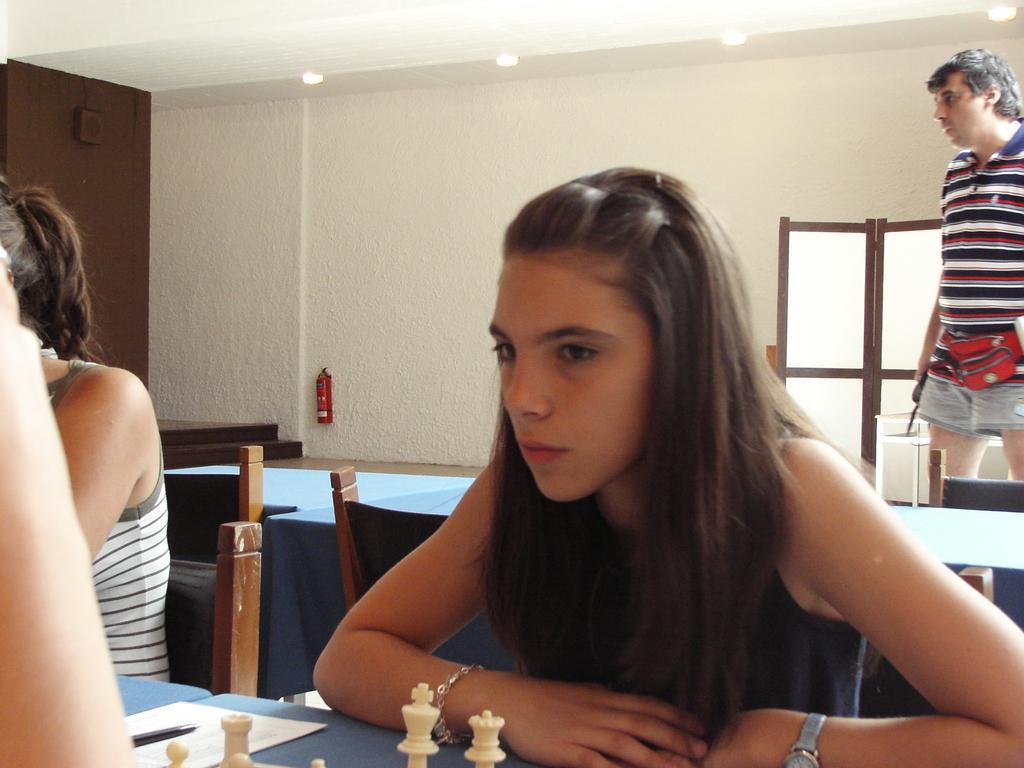How would you summarize this image in a sentence or two? At the top we can see ceiling and lights. This is a wall, window. We can see one person standing near to the table. We can see persons sitting on chairs in front of a table and on the table we can see paper, pen and chess pieces. 